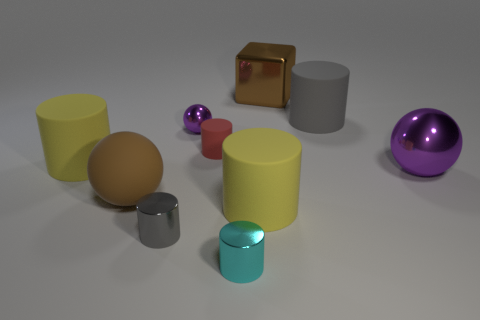Subtract all cyan cylinders. How many cylinders are left? 5 Subtract all gray matte cylinders. How many cylinders are left? 5 Subtract all red cylinders. Subtract all brown balls. How many cylinders are left? 5 Subtract all cylinders. How many objects are left? 4 Subtract all brown shiny cubes. Subtract all tiny cyan metallic cylinders. How many objects are left? 8 Add 3 small red rubber cylinders. How many small red rubber cylinders are left? 4 Add 6 tiny gray cylinders. How many tiny gray cylinders exist? 7 Subtract 0 blue cylinders. How many objects are left? 10 